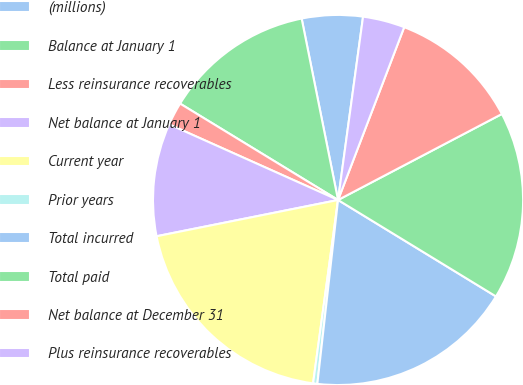Convert chart to OTSL. <chart><loc_0><loc_0><loc_500><loc_500><pie_chart><fcel>(millions)<fcel>Balance at January 1<fcel>Less reinsurance recoverables<fcel>Net balance at January 1<fcel>Current year<fcel>Prior years<fcel>Total incurred<fcel>Total paid<fcel>Net balance at December 31<fcel>Plus reinsurance recoverables<nl><fcel>5.31%<fcel>13.13%<fcel>2.02%<fcel>9.84%<fcel>19.71%<fcel>0.37%<fcel>18.06%<fcel>16.42%<fcel>11.49%<fcel>3.66%<nl></chart> 